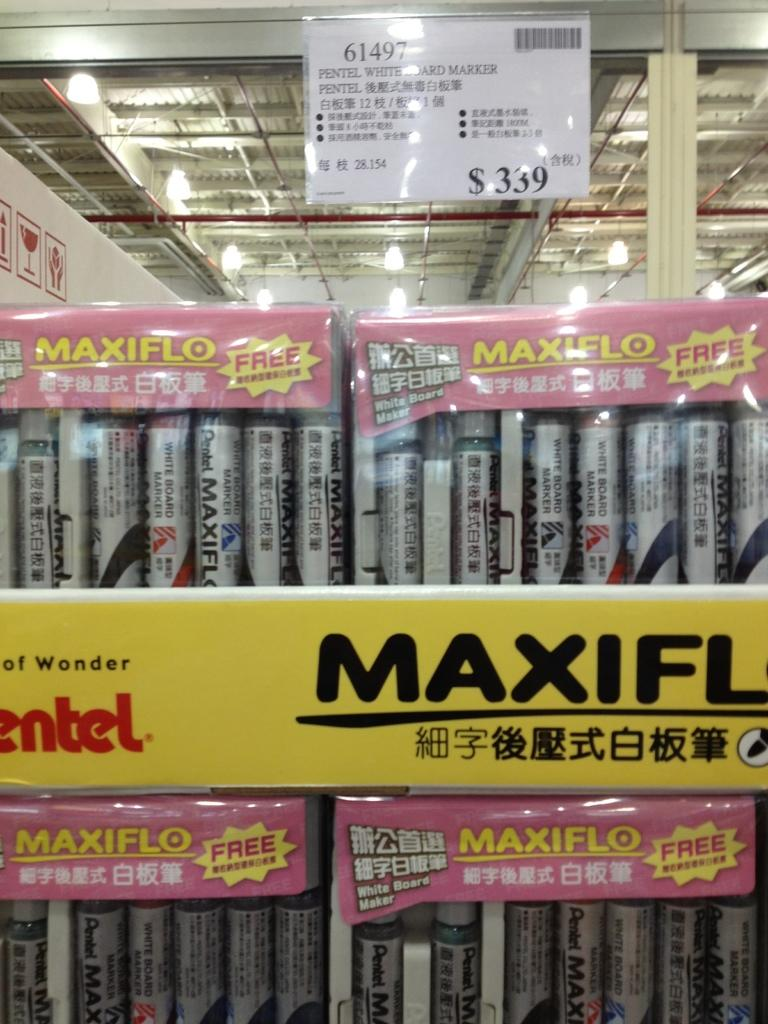<image>
Write a terse but informative summary of the picture. Store that has products for sale and a yellow sign that says Maxiflo. 